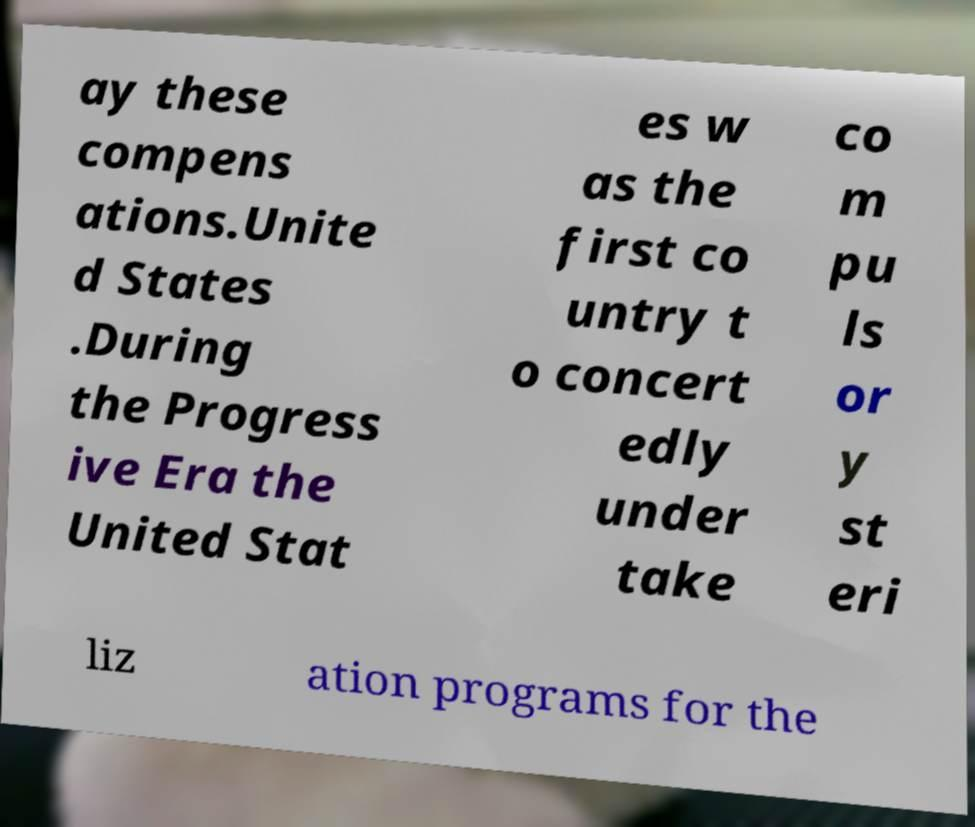Please read and relay the text visible in this image. What does it say? ay these compens ations.Unite d States .During the Progress ive Era the United Stat es w as the first co untry t o concert edly under take co m pu ls or y st eri liz ation programs for the 